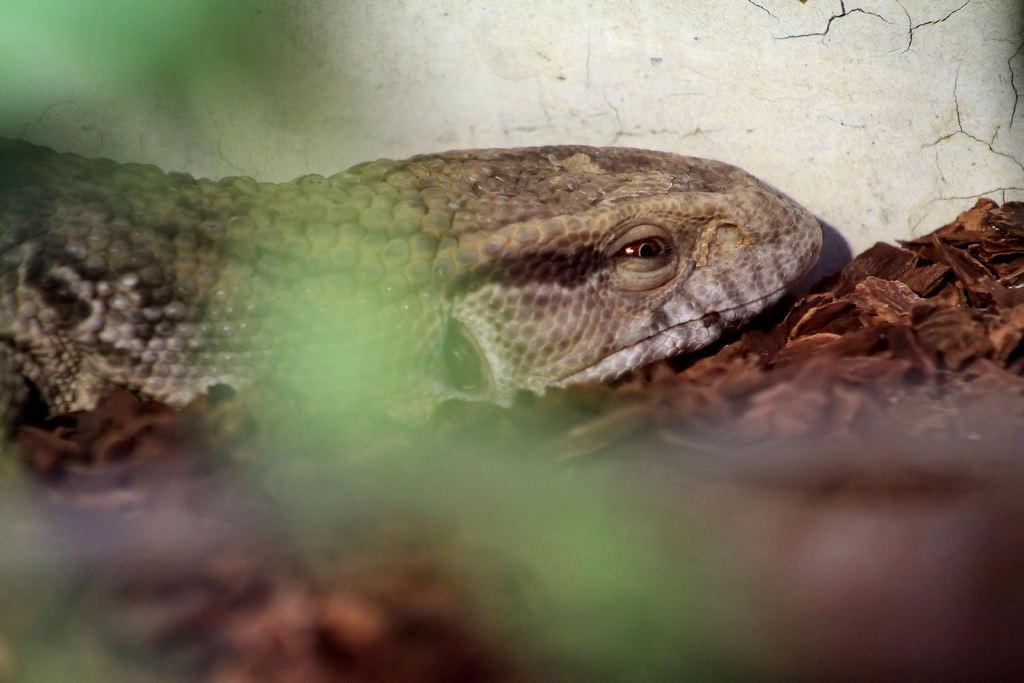How would you summarize this image in a sentence or two? In the picture there is some animal, under the animal there are many wooden pieces, in the background there is a wall. 